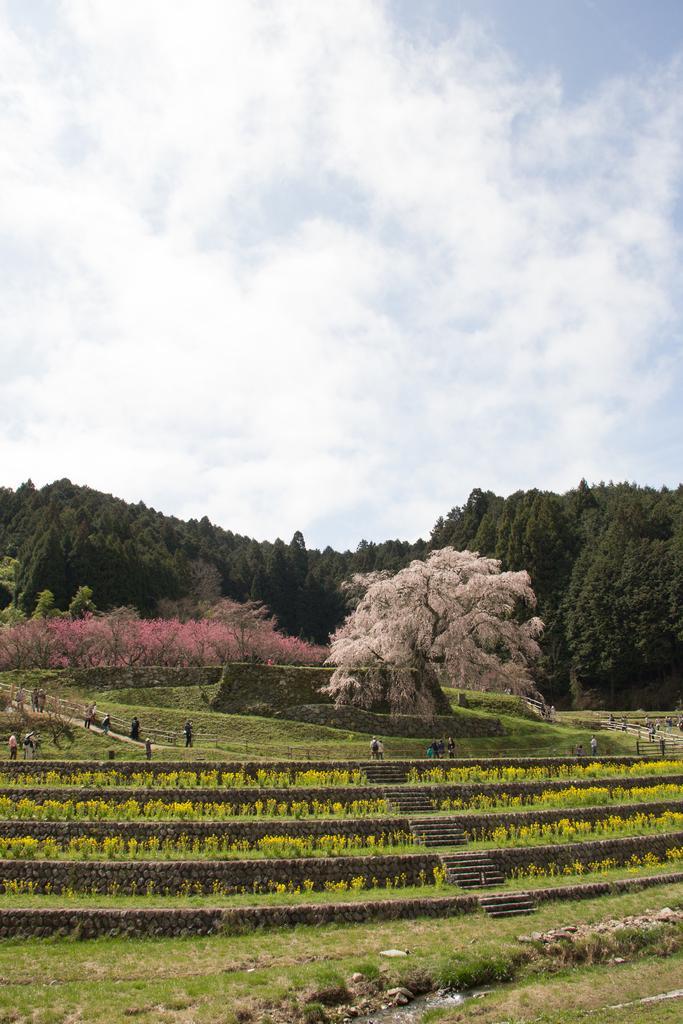In one or two sentences, can you explain what this image depicts? In this picture we can see grass, some stones, plants and flowers at the bottom, there are some people standing in the middle, we can also see stairs in the middle, in the background there are some trees, we can see the sky at the top of the picture. 